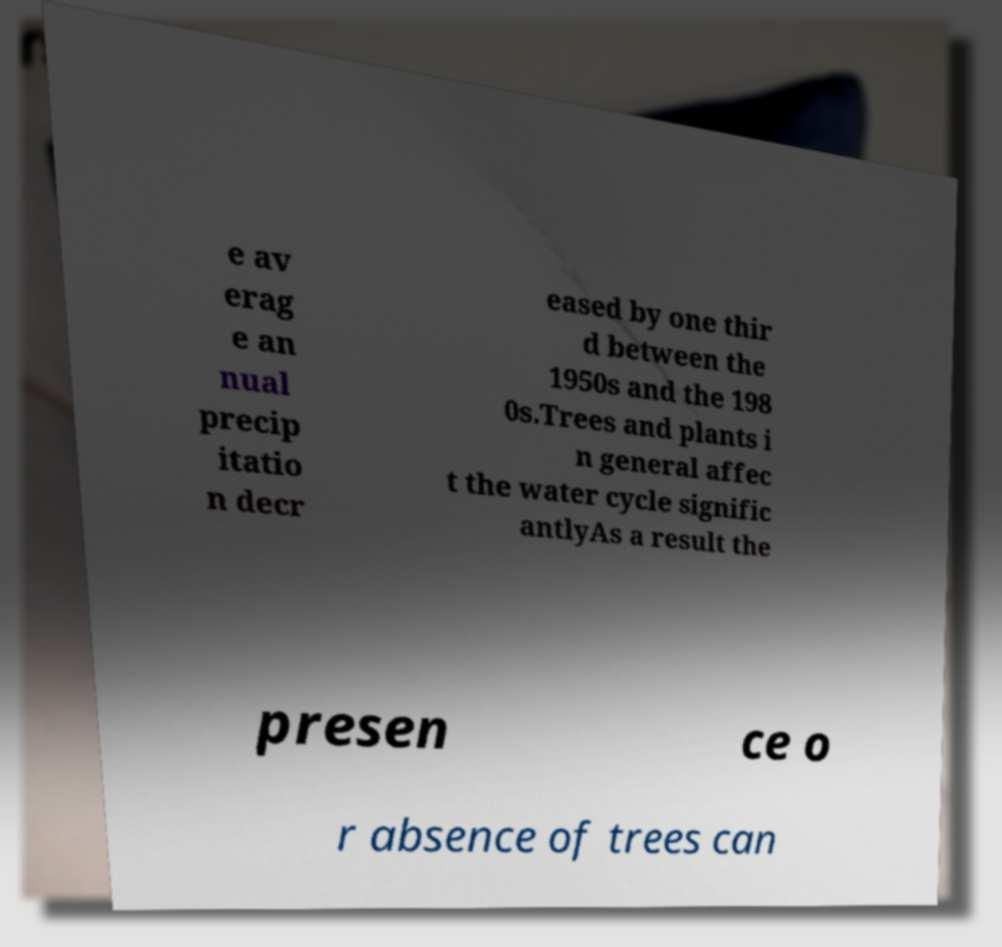For documentation purposes, I need the text within this image transcribed. Could you provide that? e av erag e an nual precip itatio n decr eased by one thir d between the 1950s and the 198 0s.Trees and plants i n general affec t the water cycle signific antlyAs a result the presen ce o r absence of trees can 